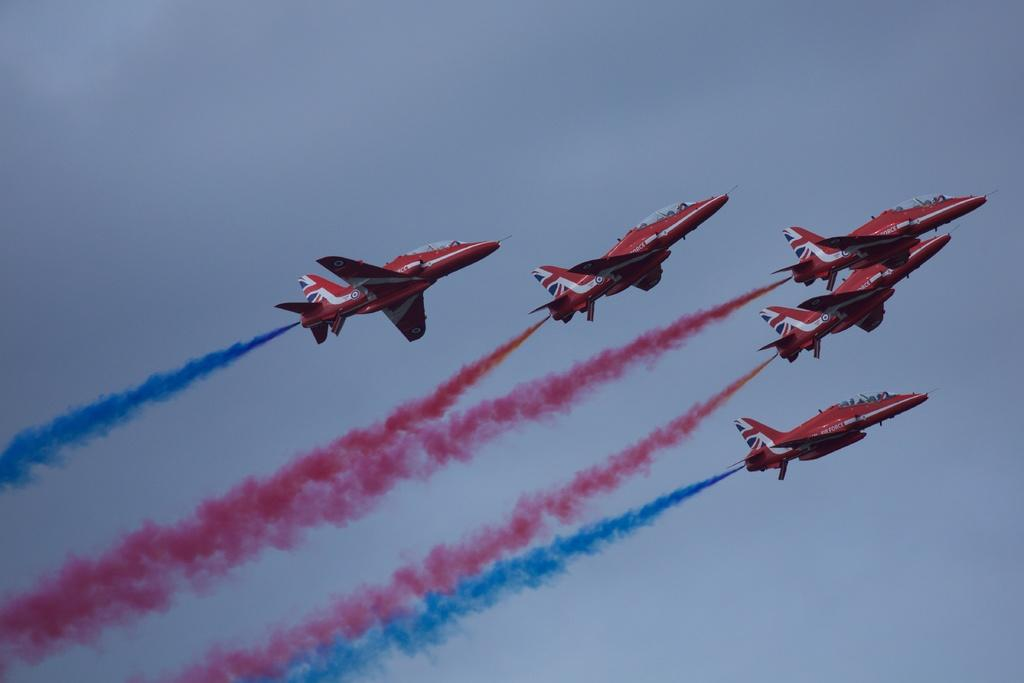What is in the sky in the image? There are rockets visible in the sky, and there is a colorful fog visible as well. What can be seen in the background of the image? The sky is visible in the background of the image. How many elbows can be seen on the rockets in the image? There are no elbows present on the rockets in the image, as rockets do not have elbows. 